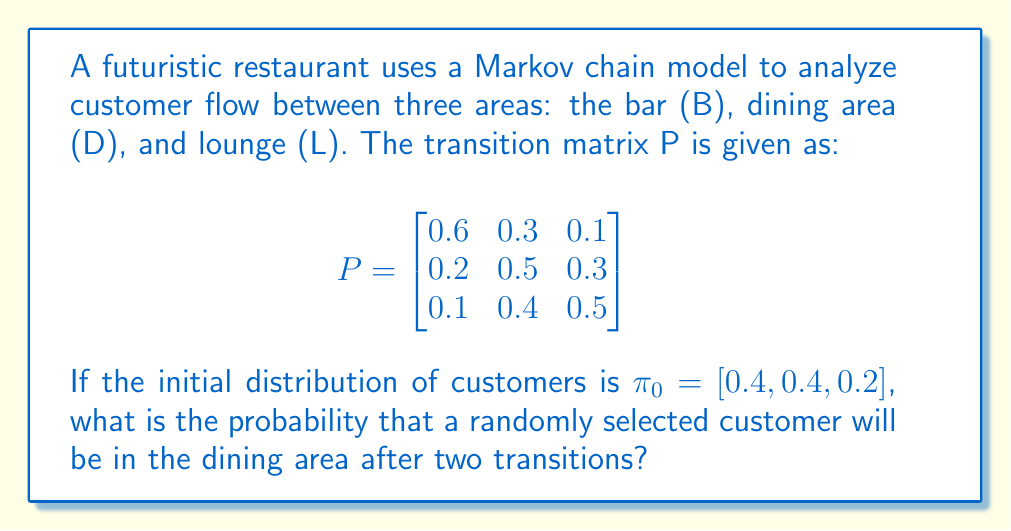Show me your answer to this math problem. To solve this problem, we need to calculate the distribution of customers after two transitions using the given initial distribution and transition matrix. We'll follow these steps:

1. Calculate $\pi_1 = \pi_0 P$:
   $$\pi_1 = [0.4, 0.4, 0.2] \begin{bmatrix}
   0.6 & 0.3 & 0.1 \\
   0.2 & 0.5 & 0.3 \\
   0.1 & 0.4 & 0.5
   \end{bmatrix}$$

   $\pi_1 = [0.4(0.6) + 0.4(0.2) + 0.2(0.1), 0.4(0.3) + 0.4(0.5) + 0.2(0.4), 0.4(0.1) + 0.4(0.3) + 0.2(0.5)]$
   $\pi_1 = [0.34, 0.40, 0.26]$

2. Calculate $\pi_2 = \pi_1 P$:
   $$\pi_2 = [0.34, 0.40, 0.26] \begin{bmatrix}
   0.6 & 0.3 & 0.1 \\
   0.2 & 0.5 & 0.3 \\
   0.1 & 0.4 & 0.5
   \end{bmatrix}$$

   $\pi_2 = [0.34(0.6) + 0.40(0.2) + 0.26(0.1), 0.34(0.3) + 0.40(0.5) + 0.26(0.4), 0.34(0.1) + 0.40(0.3) + 0.26(0.5)]$
   $\pi_2 = [0.326, 0.394, 0.280]$

3. The probability of a customer being in the dining area (D) after two transitions is the second element of $\pi_2$, which is 0.394 or 39.4%.
Answer: 0.394 